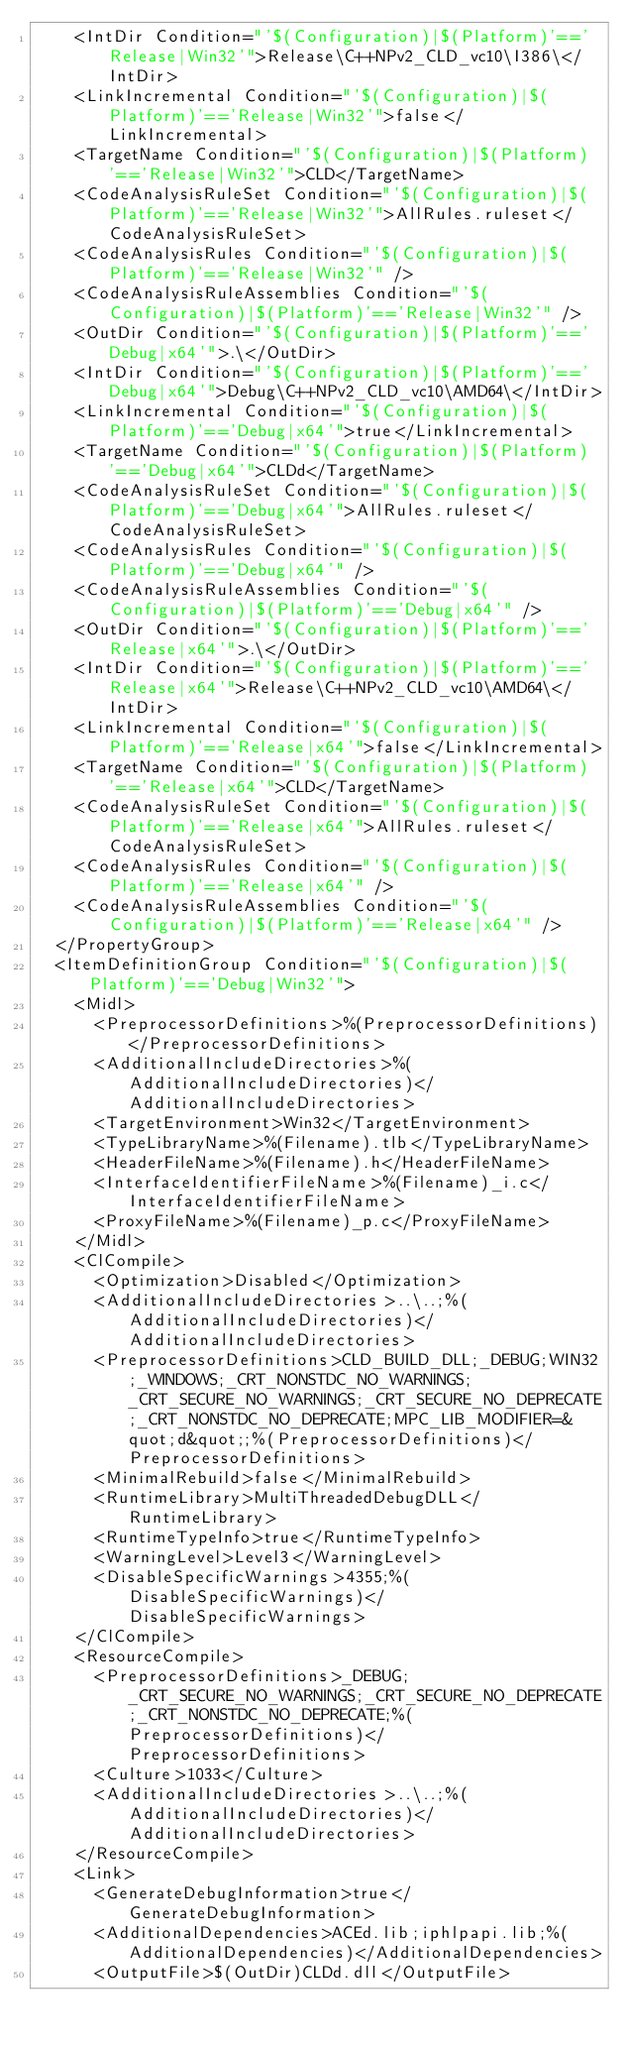<code> <loc_0><loc_0><loc_500><loc_500><_XML_>    <IntDir Condition="'$(Configuration)|$(Platform)'=='Release|Win32'">Release\C++NPv2_CLD_vc10\I386\</IntDir>
    <LinkIncremental Condition="'$(Configuration)|$(Platform)'=='Release|Win32'">false</LinkIncremental>
    <TargetName Condition="'$(Configuration)|$(Platform)'=='Release|Win32'">CLD</TargetName>
    <CodeAnalysisRuleSet Condition="'$(Configuration)|$(Platform)'=='Release|Win32'">AllRules.ruleset</CodeAnalysisRuleSet>
    <CodeAnalysisRules Condition="'$(Configuration)|$(Platform)'=='Release|Win32'" />
    <CodeAnalysisRuleAssemblies Condition="'$(Configuration)|$(Platform)'=='Release|Win32'" />
    <OutDir Condition="'$(Configuration)|$(Platform)'=='Debug|x64'">.\</OutDir>
    <IntDir Condition="'$(Configuration)|$(Platform)'=='Debug|x64'">Debug\C++NPv2_CLD_vc10\AMD64\</IntDir>
    <LinkIncremental Condition="'$(Configuration)|$(Platform)'=='Debug|x64'">true</LinkIncremental>
    <TargetName Condition="'$(Configuration)|$(Platform)'=='Debug|x64'">CLDd</TargetName>
    <CodeAnalysisRuleSet Condition="'$(Configuration)|$(Platform)'=='Debug|x64'">AllRules.ruleset</CodeAnalysisRuleSet>
    <CodeAnalysisRules Condition="'$(Configuration)|$(Platform)'=='Debug|x64'" />
    <CodeAnalysisRuleAssemblies Condition="'$(Configuration)|$(Platform)'=='Debug|x64'" />
    <OutDir Condition="'$(Configuration)|$(Platform)'=='Release|x64'">.\</OutDir>
    <IntDir Condition="'$(Configuration)|$(Platform)'=='Release|x64'">Release\C++NPv2_CLD_vc10\AMD64\</IntDir>
    <LinkIncremental Condition="'$(Configuration)|$(Platform)'=='Release|x64'">false</LinkIncremental>
    <TargetName Condition="'$(Configuration)|$(Platform)'=='Release|x64'">CLD</TargetName>
    <CodeAnalysisRuleSet Condition="'$(Configuration)|$(Platform)'=='Release|x64'">AllRules.ruleset</CodeAnalysisRuleSet>
    <CodeAnalysisRules Condition="'$(Configuration)|$(Platform)'=='Release|x64'" />
    <CodeAnalysisRuleAssemblies Condition="'$(Configuration)|$(Platform)'=='Release|x64'" />
  </PropertyGroup>
  <ItemDefinitionGroup Condition="'$(Configuration)|$(Platform)'=='Debug|Win32'">
    <Midl>
      <PreprocessorDefinitions>%(PreprocessorDefinitions)</PreprocessorDefinitions>
      <AdditionalIncludeDirectories>%(AdditionalIncludeDirectories)</AdditionalIncludeDirectories>
      <TargetEnvironment>Win32</TargetEnvironment>
      <TypeLibraryName>%(Filename).tlb</TypeLibraryName>
      <HeaderFileName>%(Filename).h</HeaderFileName>
      <InterfaceIdentifierFileName>%(Filename)_i.c</InterfaceIdentifierFileName>
      <ProxyFileName>%(Filename)_p.c</ProxyFileName>
    </Midl>
    <ClCompile>
      <Optimization>Disabled</Optimization>
      <AdditionalIncludeDirectories>..\..;%(AdditionalIncludeDirectories)</AdditionalIncludeDirectories>
      <PreprocessorDefinitions>CLD_BUILD_DLL;_DEBUG;WIN32;_WINDOWS;_CRT_NONSTDC_NO_WARNINGS;_CRT_SECURE_NO_WARNINGS;_CRT_SECURE_NO_DEPRECATE;_CRT_NONSTDC_NO_DEPRECATE;MPC_LIB_MODIFIER=&quot;d&quot;;%(PreprocessorDefinitions)</PreprocessorDefinitions>
      <MinimalRebuild>false</MinimalRebuild>
      <RuntimeLibrary>MultiThreadedDebugDLL</RuntimeLibrary>
      <RuntimeTypeInfo>true</RuntimeTypeInfo>
      <WarningLevel>Level3</WarningLevel>
      <DisableSpecificWarnings>4355;%(DisableSpecificWarnings)</DisableSpecificWarnings>
    </ClCompile>
    <ResourceCompile>
      <PreprocessorDefinitions>_DEBUG;_CRT_SECURE_NO_WARNINGS;_CRT_SECURE_NO_DEPRECATE;_CRT_NONSTDC_NO_DEPRECATE;%(PreprocessorDefinitions)</PreprocessorDefinitions>
      <Culture>1033</Culture>
      <AdditionalIncludeDirectories>..\..;%(AdditionalIncludeDirectories)</AdditionalIncludeDirectories>
    </ResourceCompile>
    <Link>
      <GenerateDebugInformation>true</GenerateDebugInformation>
      <AdditionalDependencies>ACEd.lib;iphlpapi.lib;%(AdditionalDependencies)</AdditionalDependencies>
      <OutputFile>$(OutDir)CLDd.dll</OutputFile></code> 